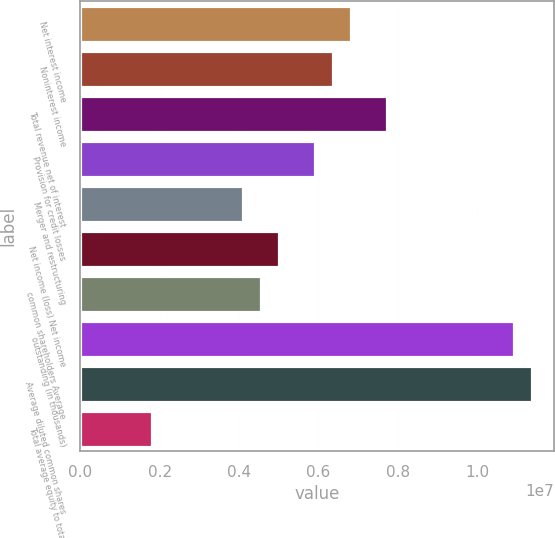Convert chart to OTSL. <chart><loc_0><loc_0><loc_500><loc_500><bar_chart><fcel>Net interest income<fcel>Noninterest income<fcel>Total revenue net of interest<fcel>Provision for credit losses<fcel>Merger and restructuring<fcel>Net income (loss) Net income<fcel>common shareholders Average<fcel>outstanding (in thousands)<fcel>Average diluted common shares<fcel>Total average equity to total<nl><fcel>6.82137e+06<fcel>6.36661e+06<fcel>7.73088e+06<fcel>5.91185e+06<fcel>4.09282e+06<fcel>5.00234e+06<fcel>4.54758e+06<fcel>1.09142e+07<fcel>1.13689e+07<fcel>1.81903e+06<nl></chart> 